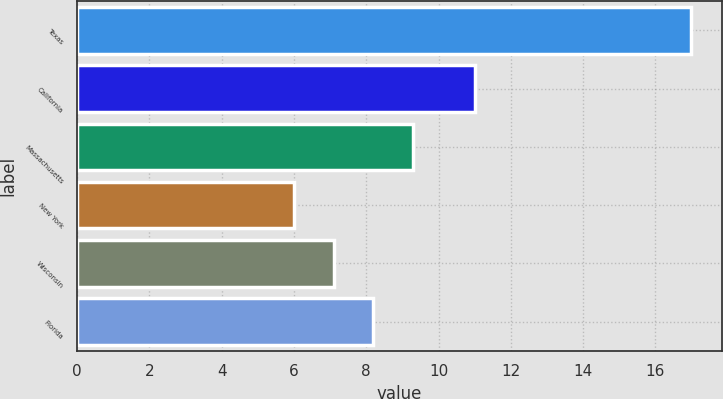Convert chart to OTSL. <chart><loc_0><loc_0><loc_500><loc_500><bar_chart><fcel>Texas<fcel>California<fcel>Massachusetts<fcel>New York<fcel>Wisconsin<fcel>Florida<nl><fcel>17<fcel>11<fcel>9.3<fcel>6<fcel>7.1<fcel>8.2<nl></chart> 